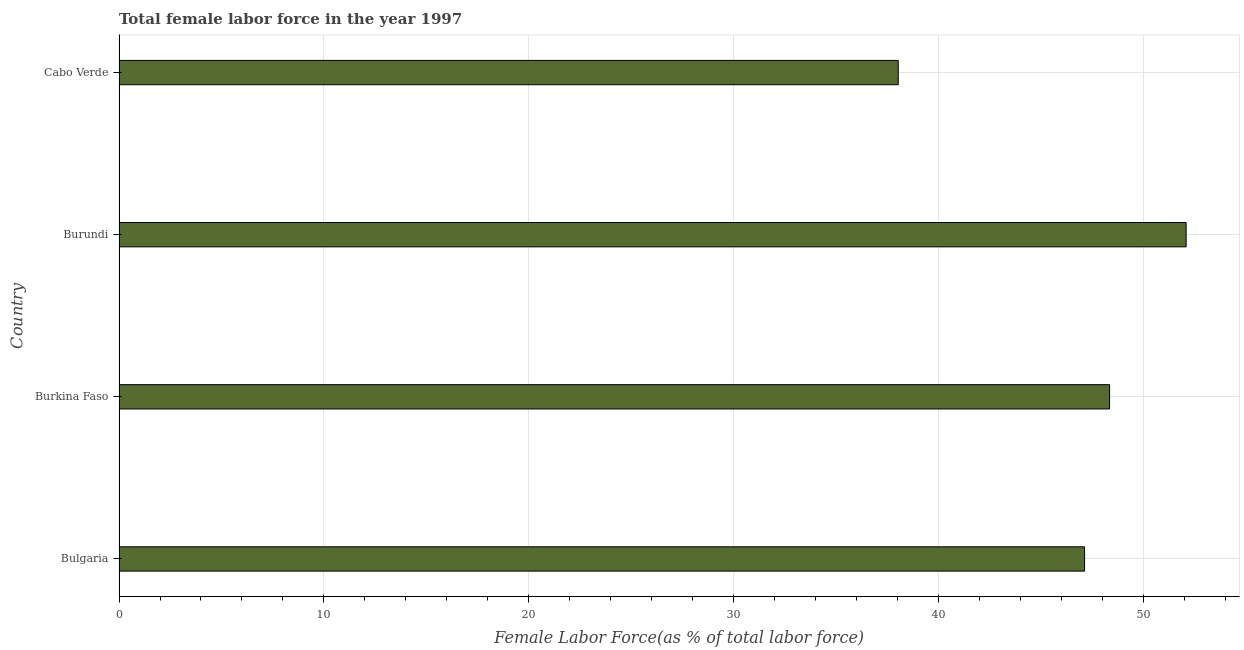Does the graph contain any zero values?
Keep it short and to the point. No. What is the title of the graph?
Provide a succinct answer. Total female labor force in the year 1997. What is the label or title of the X-axis?
Provide a succinct answer. Female Labor Force(as % of total labor force). What is the total female labor force in Bulgaria?
Make the answer very short. 47.14. Across all countries, what is the maximum total female labor force?
Provide a short and direct response. 52.1. Across all countries, what is the minimum total female labor force?
Make the answer very short. 38.05. In which country was the total female labor force maximum?
Offer a very short reply. Burundi. In which country was the total female labor force minimum?
Make the answer very short. Cabo Verde. What is the sum of the total female labor force?
Your response must be concise. 185.65. What is the difference between the total female labor force in Burkina Faso and Burundi?
Give a very brief answer. -3.74. What is the average total female labor force per country?
Your answer should be compact. 46.41. What is the median total female labor force?
Provide a succinct answer. 47.75. In how many countries, is the total female labor force greater than 48 %?
Your response must be concise. 2. What is the ratio of the total female labor force in Bulgaria to that in Burundi?
Make the answer very short. 0.91. Is the total female labor force in Bulgaria less than that in Cabo Verde?
Your response must be concise. No. What is the difference between the highest and the second highest total female labor force?
Your answer should be compact. 3.74. What is the difference between the highest and the lowest total female labor force?
Provide a succinct answer. 14.06. How many bars are there?
Your answer should be compact. 4. How many countries are there in the graph?
Your response must be concise. 4. Are the values on the major ticks of X-axis written in scientific E-notation?
Make the answer very short. No. What is the Female Labor Force(as % of total labor force) in Bulgaria?
Your response must be concise. 47.14. What is the Female Labor Force(as % of total labor force) of Burkina Faso?
Provide a succinct answer. 48.36. What is the Female Labor Force(as % of total labor force) of Burundi?
Keep it short and to the point. 52.1. What is the Female Labor Force(as % of total labor force) in Cabo Verde?
Make the answer very short. 38.05. What is the difference between the Female Labor Force(as % of total labor force) in Bulgaria and Burkina Faso?
Your answer should be compact. -1.22. What is the difference between the Female Labor Force(as % of total labor force) in Bulgaria and Burundi?
Your response must be concise. -4.96. What is the difference between the Female Labor Force(as % of total labor force) in Bulgaria and Cabo Verde?
Provide a short and direct response. 9.1. What is the difference between the Female Labor Force(as % of total labor force) in Burkina Faso and Burundi?
Your answer should be compact. -3.74. What is the difference between the Female Labor Force(as % of total labor force) in Burkina Faso and Cabo Verde?
Your answer should be compact. 10.32. What is the difference between the Female Labor Force(as % of total labor force) in Burundi and Cabo Verde?
Offer a terse response. 14.06. What is the ratio of the Female Labor Force(as % of total labor force) in Bulgaria to that in Burundi?
Give a very brief answer. 0.91. What is the ratio of the Female Labor Force(as % of total labor force) in Bulgaria to that in Cabo Verde?
Provide a succinct answer. 1.24. What is the ratio of the Female Labor Force(as % of total labor force) in Burkina Faso to that in Burundi?
Keep it short and to the point. 0.93. What is the ratio of the Female Labor Force(as % of total labor force) in Burkina Faso to that in Cabo Verde?
Keep it short and to the point. 1.27. What is the ratio of the Female Labor Force(as % of total labor force) in Burundi to that in Cabo Verde?
Offer a very short reply. 1.37. 